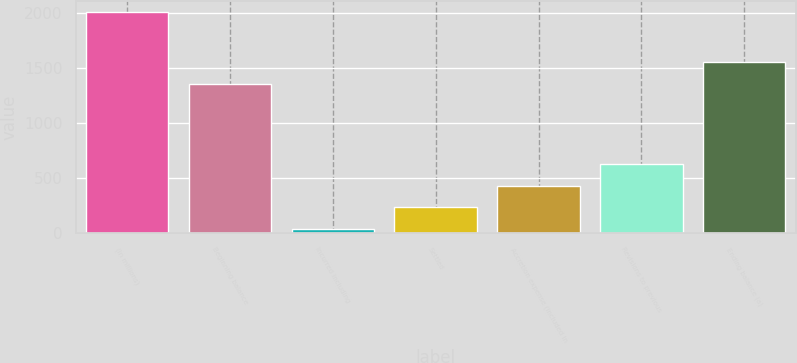Convert chart to OTSL. <chart><loc_0><loc_0><loc_500><loc_500><bar_chart><fcel>(In millions)<fcel>Beginning balance<fcel>Incurred including<fcel>Settled<fcel>Accretion expense (included in<fcel>Revisions to previous<fcel>Ending balance (a)<nl><fcel>2011<fcel>1355<fcel>37<fcel>234.4<fcel>431.8<fcel>629.2<fcel>1552.4<nl></chart> 